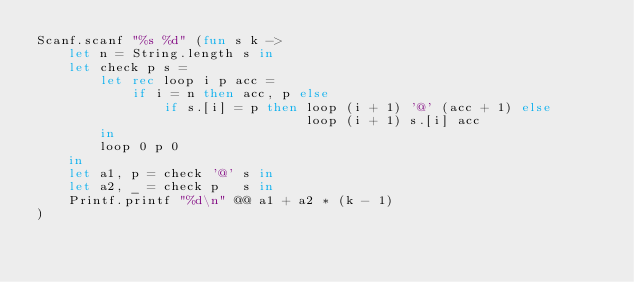Convert code to text. <code><loc_0><loc_0><loc_500><loc_500><_OCaml_>Scanf.scanf "%s %d" (fun s k ->
    let n = String.length s in
    let check p s =
        let rec loop i p acc =
            if i = n then acc, p else
                if s.[i] = p then loop (i + 1) '@' (acc + 1) else
                                  loop (i + 1) s.[i] acc
        in
        loop 0 p 0
    in
    let a1, p = check '@' s in
    let a2, _ = check p   s in
    Printf.printf "%d\n" @@ a1 + a2 * (k - 1)
)</code> 